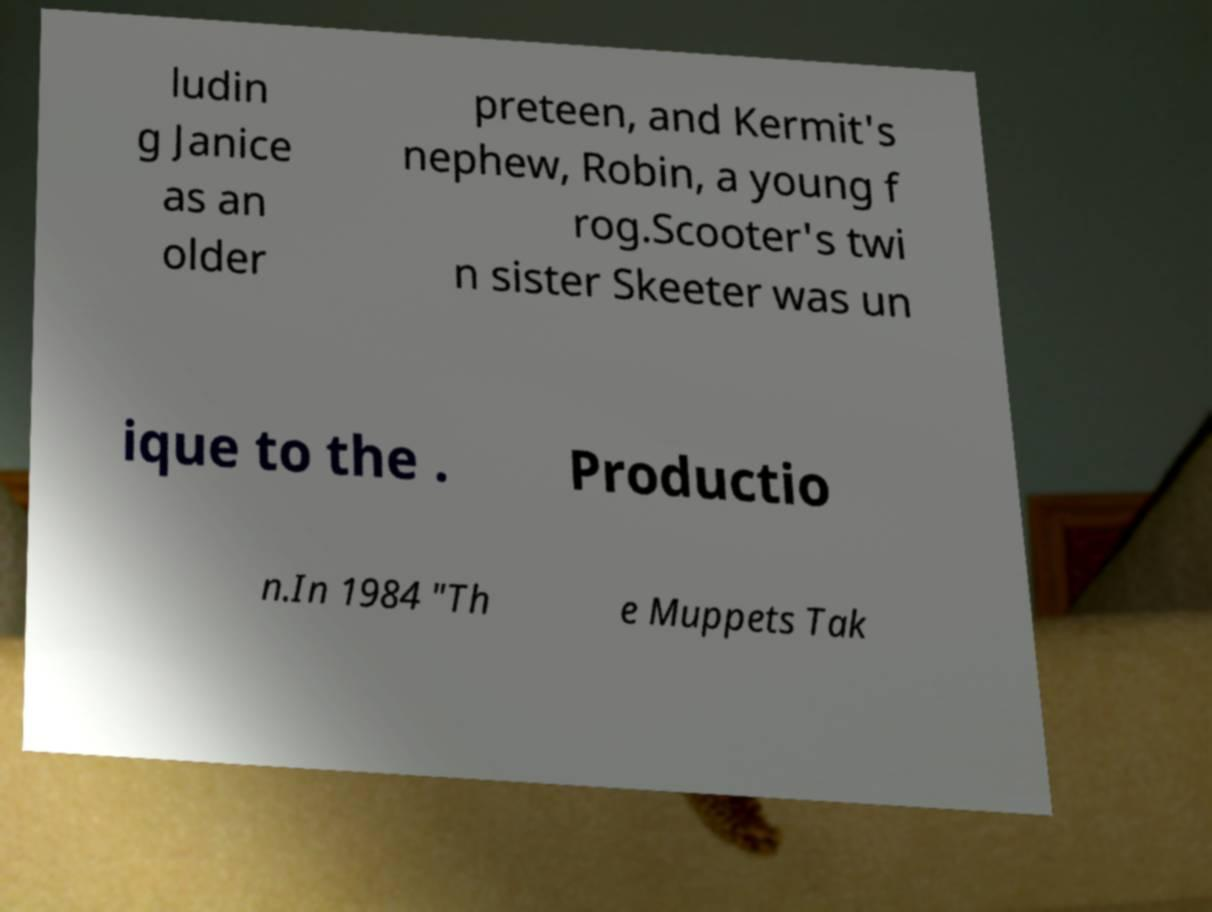Could you extract and type out the text from this image? ludin g Janice as an older preteen, and Kermit's nephew, Robin, a young f rog.Scooter's twi n sister Skeeter was un ique to the . Productio n.In 1984 "Th e Muppets Tak 